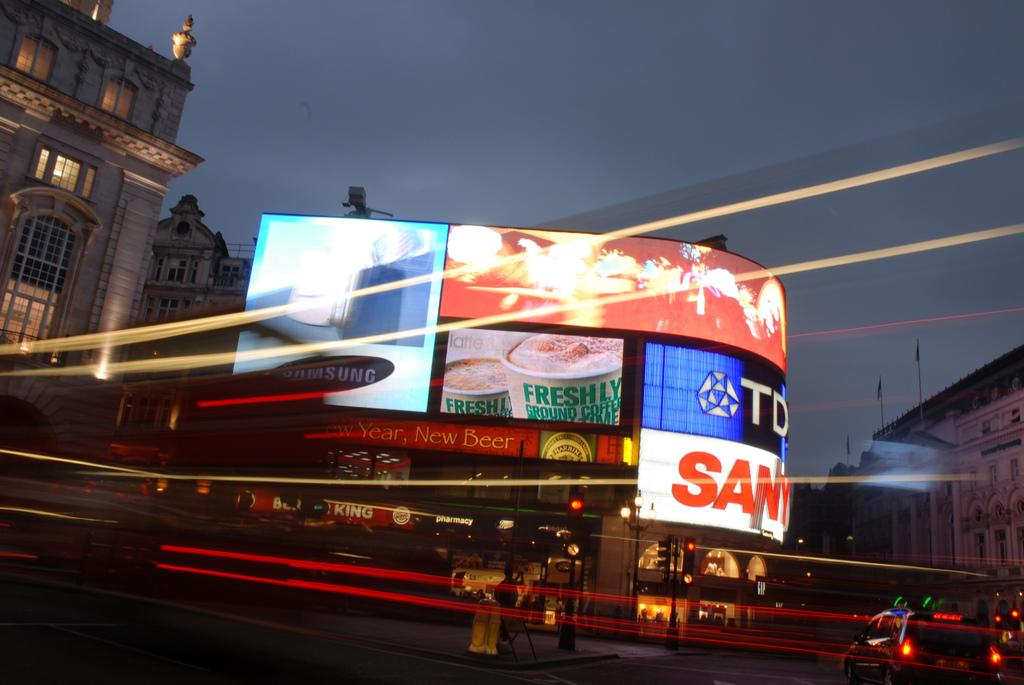<image>
Present a compact description of the photo's key features. A group of giant TV screens with one having the Samsung logo on it. 